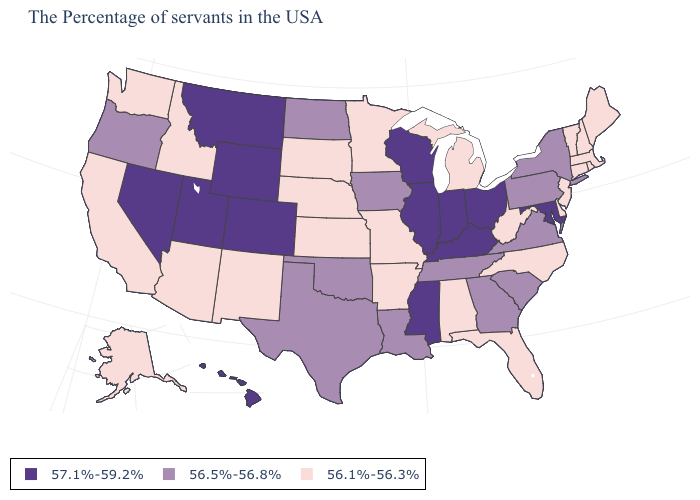Does Utah have the highest value in the USA?
Answer briefly. Yes. What is the value of Washington?
Be succinct. 56.1%-56.3%. What is the value of West Virginia?
Quick response, please. 56.1%-56.3%. What is the value of Wyoming?
Write a very short answer. 57.1%-59.2%. Does New Hampshire have the highest value in the USA?
Be succinct. No. Name the states that have a value in the range 56.1%-56.3%?
Quick response, please. Maine, Massachusetts, Rhode Island, New Hampshire, Vermont, Connecticut, New Jersey, Delaware, North Carolina, West Virginia, Florida, Michigan, Alabama, Missouri, Arkansas, Minnesota, Kansas, Nebraska, South Dakota, New Mexico, Arizona, Idaho, California, Washington, Alaska. Does North Dakota have the highest value in the MidWest?
Short answer required. No. Does New York have the highest value in the Northeast?
Be succinct. Yes. How many symbols are there in the legend?
Keep it brief. 3. How many symbols are there in the legend?
Be succinct. 3. What is the value of West Virginia?
Quick response, please. 56.1%-56.3%. Which states have the highest value in the USA?
Quick response, please. Maryland, Ohio, Kentucky, Indiana, Wisconsin, Illinois, Mississippi, Wyoming, Colorado, Utah, Montana, Nevada, Hawaii. How many symbols are there in the legend?
Be succinct. 3. What is the lowest value in states that border Rhode Island?
Concise answer only. 56.1%-56.3%. Among the states that border California , which have the lowest value?
Short answer required. Arizona. 